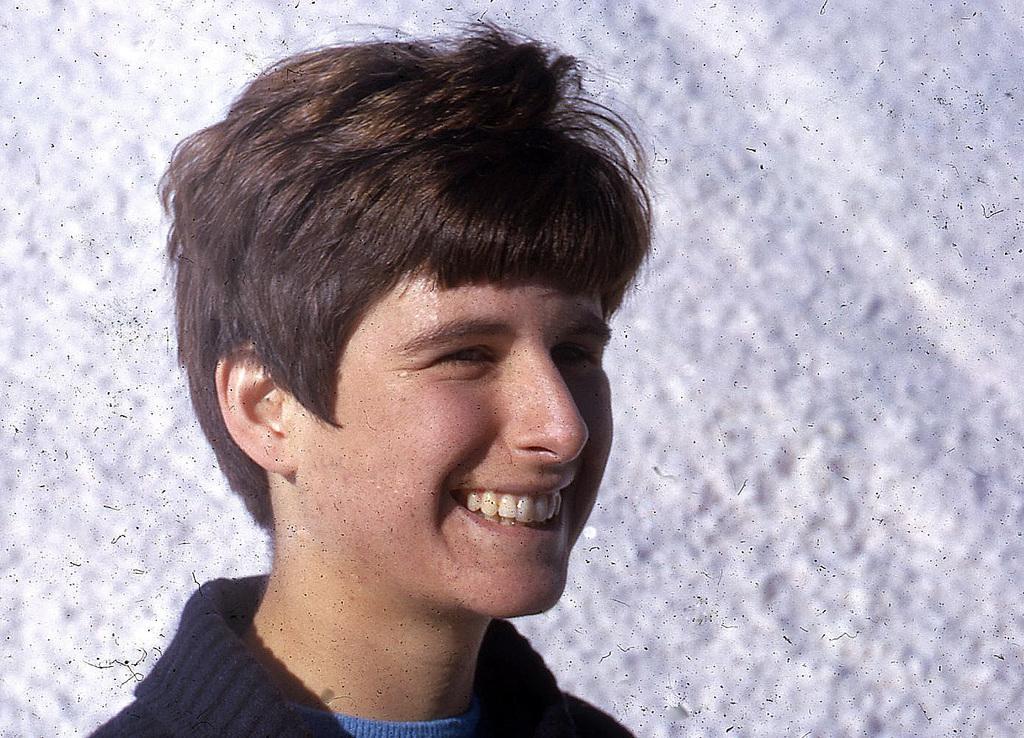In one or two sentences, can you explain what this image depicts? In this image, we can see a boy smiling, the background is not clear. 